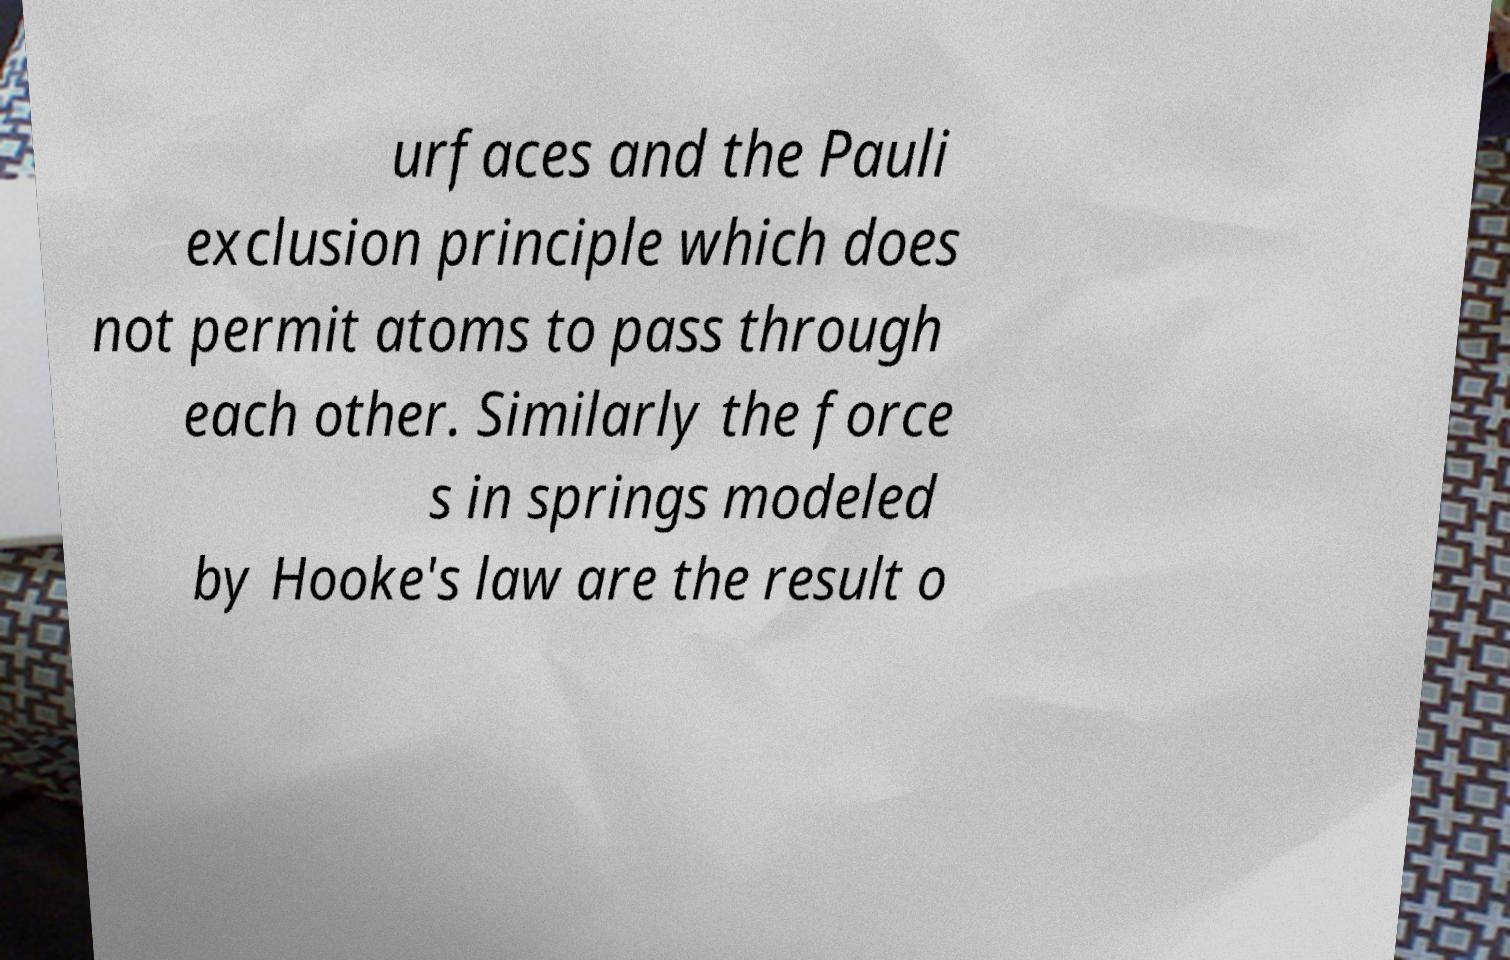Please read and relay the text visible in this image. What does it say? urfaces and the Pauli exclusion principle which does not permit atoms to pass through each other. Similarly the force s in springs modeled by Hooke's law are the result o 